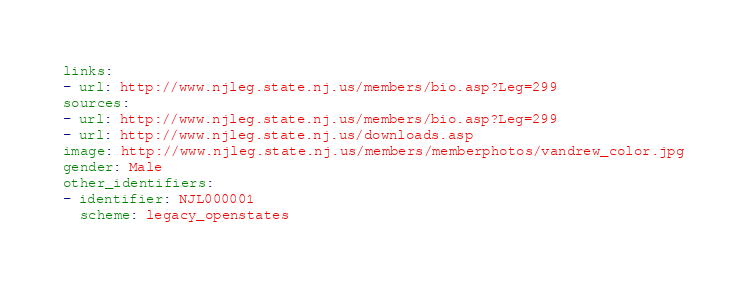Convert code to text. <code><loc_0><loc_0><loc_500><loc_500><_YAML_>links:
- url: http://www.njleg.state.nj.us/members/bio.asp?Leg=299
sources:
- url: http://www.njleg.state.nj.us/members/bio.asp?Leg=299
- url: http://www.njleg.state.nj.us/downloads.asp
image: http://www.njleg.state.nj.us/members/memberphotos/vandrew_color.jpg
gender: Male
other_identifiers:
- identifier: NJL000001
  scheme: legacy_openstates
</code> 